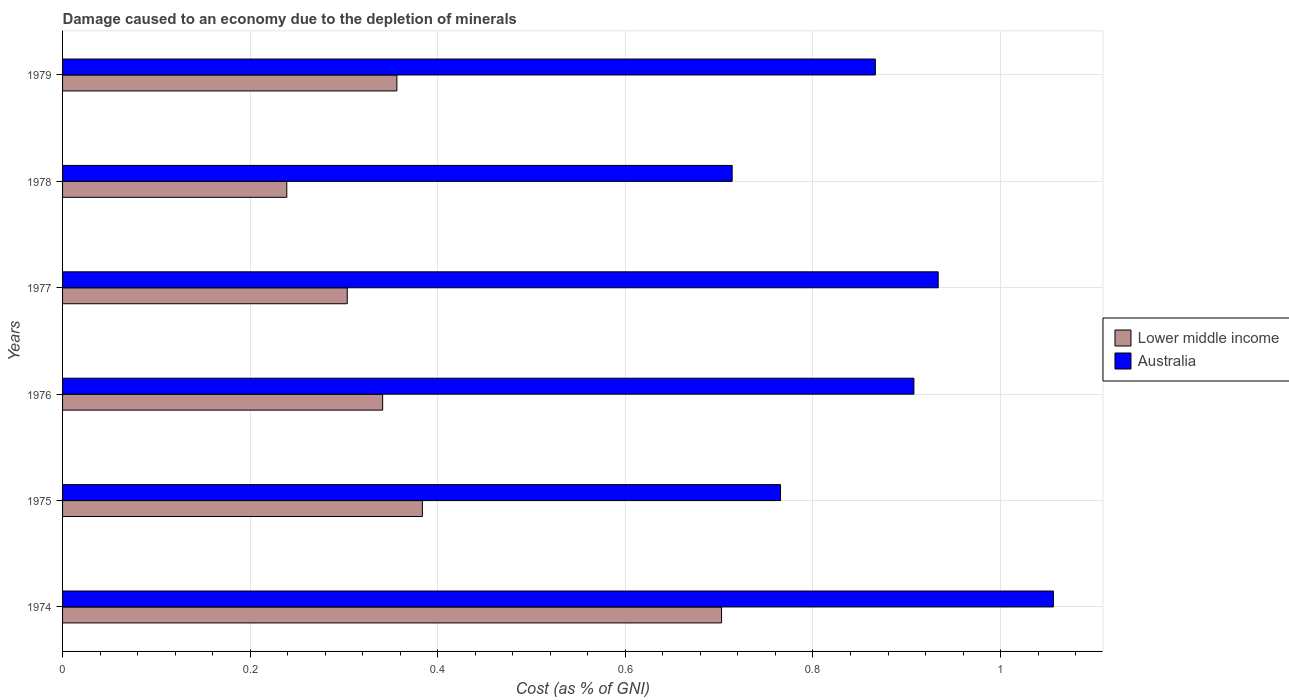How many bars are there on the 4th tick from the top?
Offer a terse response. 2. What is the label of the 3rd group of bars from the top?
Your answer should be compact. 1977. In how many cases, is the number of bars for a given year not equal to the number of legend labels?
Offer a terse response. 0. What is the cost of damage caused due to the depletion of minerals in Australia in 1978?
Provide a succinct answer. 0.71. Across all years, what is the maximum cost of damage caused due to the depletion of minerals in Lower middle income?
Your answer should be very brief. 0.7. Across all years, what is the minimum cost of damage caused due to the depletion of minerals in Australia?
Provide a short and direct response. 0.71. In which year was the cost of damage caused due to the depletion of minerals in Lower middle income maximum?
Keep it short and to the point. 1974. In which year was the cost of damage caused due to the depletion of minerals in Lower middle income minimum?
Ensure brevity in your answer.  1978. What is the total cost of damage caused due to the depletion of minerals in Lower middle income in the graph?
Keep it short and to the point. 2.33. What is the difference between the cost of damage caused due to the depletion of minerals in Lower middle income in 1976 and that in 1977?
Ensure brevity in your answer.  0.04. What is the difference between the cost of damage caused due to the depletion of minerals in Lower middle income in 1975 and the cost of damage caused due to the depletion of minerals in Australia in 1976?
Keep it short and to the point. -0.52. What is the average cost of damage caused due to the depletion of minerals in Lower middle income per year?
Make the answer very short. 0.39. In the year 1979, what is the difference between the cost of damage caused due to the depletion of minerals in Australia and cost of damage caused due to the depletion of minerals in Lower middle income?
Your answer should be very brief. 0.51. What is the ratio of the cost of damage caused due to the depletion of minerals in Lower middle income in 1974 to that in 1976?
Offer a very short reply. 2.06. Is the difference between the cost of damage caused due to the depletion of minerals in Australia in 1977 and 1979 greater than the difference between the cost of damage caused due to the depletion of minerals in Lower middle income in 1977 and 1979?
Give a very brief answer. Yes. What is the difference between the highest and the second highest cost of damage caused due to the depletion of minerals in Lower middle income?
Offer a very short reply. 0.32. What is the difference between the highest and the lowest cost of damage caused due to the depletion of minerals in Lower middle income?
Ensure brevity in your answer.  0.46. What does the 2nd bar from the top in 1974 represents?
Ensure brevity in your answer.  Lower middle income. How many years are there in the graph?
Provide a succinct answer. 6. Are the values on the major ticks of X-axis written in scientific E-notation?
Your answer should be very brief. No. Does the graph contain any zero values?
Offer a very short reply. No. How many legend labels are there?
Ensure brevity in your answer.  2. How are the legend labels stacked?
Provide a short and direct response. Vertical. What is the title of the graph?
Provide a short and direct response. Damage caused to an economy due to the depletion of minerals. Does "Bosnia and Herzegovina" appear as one of the legend labels in the graph?
Your response must be concise. No. What is the label or title of the X-axis?
Offer a very short reply. Cost (as % of GNI). What is the Cost (as % of GNI) in Lower middle income in 1974?
Offer a very short reply. 0.7. What is the Cost (as % of GNI) of Australia in 1974?
Offer a terse response. 1.06. What is the Cost (as % of GNI) of Lower middle income in 1975?
Keep it short and to the point. 0.38. What is the Cost (as % of GNI) in Australia in 1975?
Make the answer very short. 0.77. What is the Cost (as % of GNI) of Lower middle income in 1976?
Your answer should be very brief. 0.34. What is the Cost (as % of GNI) in Australia in 1976?
Ensure brevity in your answer.  0.91. What is the Cost (as % of GNI) of Lower middle income in 1977?
Provide a succinct answer. 0.3. What is the Cost (as % of GNI) of Australia in 1977?
Ensure brevity in your answer.  0.93. What is the Cost (as % of GNI) in Lower middle income in 1978?
Your answer should be compact. 0.24. What is the Cost (as % of GNI) of Australia in 1978?
Offer a terse response. 0.71. What is the Cost (as % of GNI) in Lower middle income in 1979?
Your answer should be compact. 0.36. What is the Cost (as % of GNI) in Australia in 1979?
Ensure brevity in your answer.  0.87. Across all years, what is the maximum Cost (as % of GNI) of Lower middle income?
Make the answer very short. 0.7. Across all years, what is the maximum Cost (as % of GNI) in Australia?
Your answer should be very brief. 1.06. Across all years, what is the minimum Cost (as % of GNI) in Lower middle income?
Ensure brevity in your answer.  0.24. Across all years, what is the minimum Cost (as % of GNI) in Australia?
Keep it short and to the point. 0.71. What is the total Cost (as % of GNI) of Lower middle income in the graph?
Ensure brevity in your answer.  2.33. What is the total Cost (as % of GNI) of Australia in the graph?
Ensure brevity in your answer.  5.24. What is the difference between the Cost (as % of GNI) of Lower middle income in 1974 and that in 1975?
Your response must be concise. 0.32. What is the difference between the Cost (as % of GNI) in Australia in 1974 and that in 1975?
Your response must be concise. 0.29. What is the difference between the Cost (as % of GNI) of Lower middle income in 1974 and that in 1976?
Your answer should be very brief. 0.36. What is the difference between the Cost (as % of GNI) in Australia in 1974 and that in 1976?
Ensure brevity in your answer.  0.15. What is the difference between the Cost (as % of GNI) of Lower middle income in 1974 and that in 1977?
Provide a succinct answer. 0.4. What is the difference between the Cost (as % of GNI) of Australia in 1974 and that in 1977?
Keep it short and to the point. 0.12. What is the difference between the Cost (as % of GNI) in Lower middle income in 1974 and that in 1978?
Ensure brevity in your answer.  0.46. What is the difference between the Cost (as % of GNI) in Australia in 1974 and that in 1978?
Provide a short and direct response. 0.34. What is the difference between the Cost (as % of GNI) in Lower middle income in 1974 and that in 1979?
Give a very brief answer. 0.35. What is the difference between the Cost (as % of GNI) in Australia in 1974 and that in 1979?
Provide a succinct answer. 0.19. What is the difference between the Cost (as % of GNI) in Lower middle income in 1975 and that in 1976?
Your answer should be compact. 0.04. What is the difference between the Cost (as % of GNI) in Australia in 1975 and that in 1976?
Your response must be concise. -0.14. What is the difference between the Cost (as % of GNI) of Lower middle income in 1975 and that in 1977?
Your answer should be compact. 0.08. What is the difference between the Cost (as % of GNI) of Australia in 1975 and that in 1977?
Give a very brief answer. -0.17. What is the difference between the Cost (as % of GNI) in Lower middle income in 1975 and that in 1978?
Offer a very short reply. 0.14. What is the difference between the Cost (as % of GNI) in Australia in 1975 and that in 1978?
Your answer should be very brief. 0.05. What is the difference between the Cost (as % of GNI) in Lower middle income in 1975 and that in 1979?
Keep it short and to the point. 0.03. What is the difference between the Cost (as % of GNI) of Australia in 1975 and that in 1979?
Provide a short and direct response. -0.1. What is the difference between the Cost (as % of GNI) in Lower middle income in 1976 and that in 1977?
Make the answer very short. 0.04. What is the difference between the Cost (as % of GNI) in Australia in 1976 and that in 1977?
Ensure brevity in your answer.  -0.03. What is the difference between the Cost (as % of GNI) in Lower middle income in 1976 and that in 1978?
Give a very brief answer. 0.1. What is the difference between the Cost (as % of GNI) of Australia in 1976 and that in 1978?
Make the answer very short. 0.19. What is the difference between the Cost (as % of GNI) of Lower middle income in 1976 and that in 1979?
Your response must be concise. -0.02. What is the difference between the Cost (as % of GNI) of Australia in 1976 and that in 1979?
Give a very brief answer. 0.04. What is the difference between the Cost (as % of GNI) of Lower middle income in 1977 and that in 1978?
Keep it short and to the point. 0.06. What is the difference between the Cost (as % of GNI) in Australia in 1977 and that in 1978?
Your response must be concise. 0.22. What is the difference between the Cost (as % of GNI) of Lower middle income in 1977 and that in 1979?
Your answer should be very brief. -0.05. What is the difference between the Cost (as % of GNI) of Australia in 1977 and that in 1979?
Make the answer very short. 0.07. What is the difference between the Cost (as % of GNI) in Lower middle income in 1978 and that in 1979?
Make the answer very short. -0.12. What is the difference between the Cost (as % of GNI) of Australia in 1978 and that in 1979?
Provide a succinct answer. -0.15. What is the difference between the Cost (as % of GNI) in Lower middle income in 1974 and the Cost (as % of GNI) in Australia in 1975?
Keep it short and to the point. -0.06. What is the difference between the Cost (as % of GNI) in Lower middle income in 1974 and the Cost (as % of GNI) in Australia in 1976?
Make the answer very short. -0.21. What is the difference between the Cost (as % of GNI) in Lower middle income in 1974 and the Cost (as % of GNI) in Australia in 1977?
Your answer should be very brief. -0.23. What is the difference between the Cost (as % of GNI) of Lower middle income in 1974 and the Cost (as % of GNI) of Australia in 1978?
Offer a terse response. -0.01. What is the difference between the Cost (as % of GNI) in Lower middle income in 1974 and the Cost (as % of GNI) in Australia in 1979?
Provide a succinct answer. -0.16. What is the difference between the Cost (as % of GNI) of Lower middle income in 1975 and the Cost (as % of GNI) of Australia in 1976?
Your response must be concise. -0.52. What is the difference between the Cost (as % of GNI) of Lower middle income in 1975 and the Cost (as % of GNI) of Australia in 1977?
Provide a short and direct response. -0.55. What is the difference between the Cost (as % of GNI) in Lower middle income in 1975 and the Cost (as % of GNI) in Australia in 1978?
Make the answer very short. -0.33. What is the difference between the Cost (as % of GNI) in Lower middle income in 1975 and the Cost (as % of GNI) in Australia in 1979?
Your response must be concise. -0.48. What is the difference between the Cost (as % of GNI) of Lower middle income in 1976 and the Cost (as % of GNI) of Australia in 1977?
Make the answer very short. -0.59. What is the difference between the Cost (as % of GNI) in Lower middle income in 1976 and the Cost (as % of GNI) in Australia in 1978?
Offer a very short reply. -0.37. What is the difference between the Cost (as % of GNI) in Lower middle income in 1976 and the Cost (as % of GNI) in Australia in 1979?
Make the answer very short. -0.53. What is the difference between the Cost (as % of GNI) in Lower middle income in 1977 and the Cost (as % of GNI) in Australia in 1978?
Your answer should be very brief. -0.41. What is the difference between the Cost (as % of GNI) of Lower middle income in 1977 and the Cost (as % of GNI) of Australia in 1979?
Offer a terse response. -0.56. What is the difference between the Cost (as % of GNI) in Lower middle income in 1978 and the Cost (as % of GNI) in Australia in 1979?
Your answer should be compact. -0.63. What is the average Cost (as % of GNI) of Lower middle income per year?
Your response must be concise. 0.39. What is the average Cost (as % of GNI) of Australia per year?
Keep it short and to the point. 0.87. In the year 1974, what is the difference between the Cost (as % of GNI) of Lower middle income and Cost (as % of GNI) of Australia?
Your answer should be very brief. -0.35. In the year 1975, what is the difference between the Cost (as % of GNI) in Lower middle income and Cost (as % of GNI) in Australia?
Your answer should be very brief. -0.38. In the year 1976, what is the difference between the Cost (as % of GNI) of Lower middle income and Cost (as % of GNI) of Australia?
Offer a very short reply. -0.57. In the year 1977, what is the difference between the Cost (as % of GNI) in Lower middle income and Cost (as % of GNI) in Australia?
Ensure brevity in your answer.  -0.63. In the year 1978, what is the difference between the Cost (as % of GNI) in Lower middle income and Cost (as % of GNI) in Australia?
Your response must be concise. -0.47. In the year 1979, what is the difference between the Cost (as % of GNI) in Lower middle income and Cost (as % of GNI) in Australia?
Your response must be concise. -0.51. What is the ratio of the Cost (as % of GNI) in Lower middle income in 1974 to that in 1975?
Provide a short and direct response. 1.83. What is the ratio of the Cost (as % of GNI) of Australia in 1974 to that in 1975?
Keep it short and to the point. 1.38. What is the ratio of the Cost (as % of GNI) of Lower middle income in 1974 to that in 1976?
Offer a very short reply. 2.06. What is the ratio of the Cost (as % of GNI) of Australia in 1974 to that in 1976?
Your response must be concise. 1.16. What is the ratio of the Cost (as % of GNI) of Lower middle income in 1974 to that in 1977?
Your answer should be compact. 2.31. What is the ratio of the Cost (as % of GNI) in Australia in 1974 to that in 1977?
Give a very brief answer. 1.13. What is the ratio of the Cost (as % of GNI) in Lower middle income in 1974 to that in 1978?
Your response must be concise. 2.94. What is the ratio of the Cost (as % of GNI) in Australia in 1974 to that in 1978?
Your answer should be very brief. 1.48. What is the ratio of the Cost (as % of GNI) of Lower middle income in 1974 to that in 1979?
Keep it short and to the point. 1.97. What is the ratio of the Cost (as % of GNI) of Australia in 1974 to that in 1979?
Give a very brief answer. 1.22. What is the ratio of the Cost (as % of GNI) of Lower middle income in 1975 to that in 1976?
Provide a short and direct response. 1.12. What is the ratio of the Cost (as % of GNI) of Australia in 1975 to that in 1976?
Provide a succinct answer. 0.84. What is the ratio of the Cost (as % of GNI) of Lower middle income in 1975 to that in 1977?
Your answer should be very brief. 1.26. What is the ratio of the Cost (as % of GNI) in Australia in 1975 to that in 1977?
Your answer should be compact. 0.82. What is the ratio of the Cost (as % of GNI) of Lower middle income in 1975 to that in 1978?
Your answer should be compact. 1.6. What is the ratio of the Cost (as % of GNI) of Australia in 1975 to that in 1978?
Your response must be concise. 1.07. What is the ratio of the Cost (as % of GNI) of Lower middle income in 1975 to that in 1979?
Offer a terse response. 1.08. What is the ratio of the Cost (as % of GNI) in Australia in 1975 to that in 1979?
Provide a short and direct response. 0.88. What is the ratio of the Cost (as % of GNI) in Lower middle income in 1976 to that in 1977?
Offer a terse response. 1.12. What is the ratio of the Cost (as % of GNI) in Australia in 1976 to that in 1977?
Ensure brevity in your answer.  0.97. What is the ratio of the Cost (as % of GNI) in Lower middle income in 1976 to that in 1978?
Offer a terse response. 1.43. What is the ratio of the Cost (as % of GNI) of Australia in 1976 to that in 1978?
Provide a short and direct response. 1.27. What is the ratio of the Cost (as % of GNI) in Lower middle income in 1976 to that in 1979?
Your response must be concise. 0.96. What is the ratio of the Cost (as % of GNI) of Australia in 1976 to that in 1979?
Your answer should be very brief. 1.05. What is the ratio of the Cost (as % of GNI) in Lower middle income in 1977 to that in 1978?
Offer a very short reply. 1.27. What is the ratio of the Cost (as % of GNI) in Australia in 1977 to that in 1978?
Provide a succinct answer. 1.31. What is the ratio of the Cost (as % of GNI) in Lower middle income in 1977 to that in 1979?
Your response must be concise. 0.85. What is the ratio of the Cost (as % of GNI) of Australia in 1977 to that in 1979?
Offer a very short reply. 1.08. What is the ratio of the Cost (as % of GNI) of Lower middle income in 1978 to that in 1979?
Provide a succinct answer. 0.67. What is the ratio of the Cost (as % of GNI) of Australia in 1978 to that in 1979?
Keep it short and to the point. 0.82. What is the difference between the highest and the second highest Cost (as % of GNI) in Lower middle income?
Offer a terse response. 0.32. What is the difference between the highest and the second highest Cost (as % of GNI) in Australia?
Give a very brief answer. 0.12. What is the difference between the highest and the lowest Cost (as % of GNI) of Lower middle income?
Your answer should be compact. 0.46. What is the difference between the highest and the lowest Cost (as % of GNI) of Australia?
Provide a short and direct response. 0.34. 